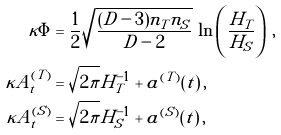Convert formula to latex. <formula><loc_0><loc_0><loc_500><loc_500>\kappa \Phi & = \frac { 1 } { 2 } \sqrt { \frac { ( D - 3 ) n _ { T } n _ { S } } { D - 2 } } \, \ln \left ( \frac { H _ { T } } { H _ { S } } \right ) \, , \\ \kappa A ^ { ( T ) } _ { t } & = \sqrt { 2 \pi } H _ { T } ^ { - 1 } + a ^ { ( T ) } ( t ) \, , \\ \kappa A ^ { ( S ) } _ { t } & = \sqrt { 2 \pi } H _ { S } ^ { - 1 } + a ^ { ( S ) } ( t ) \, ,</formula> 